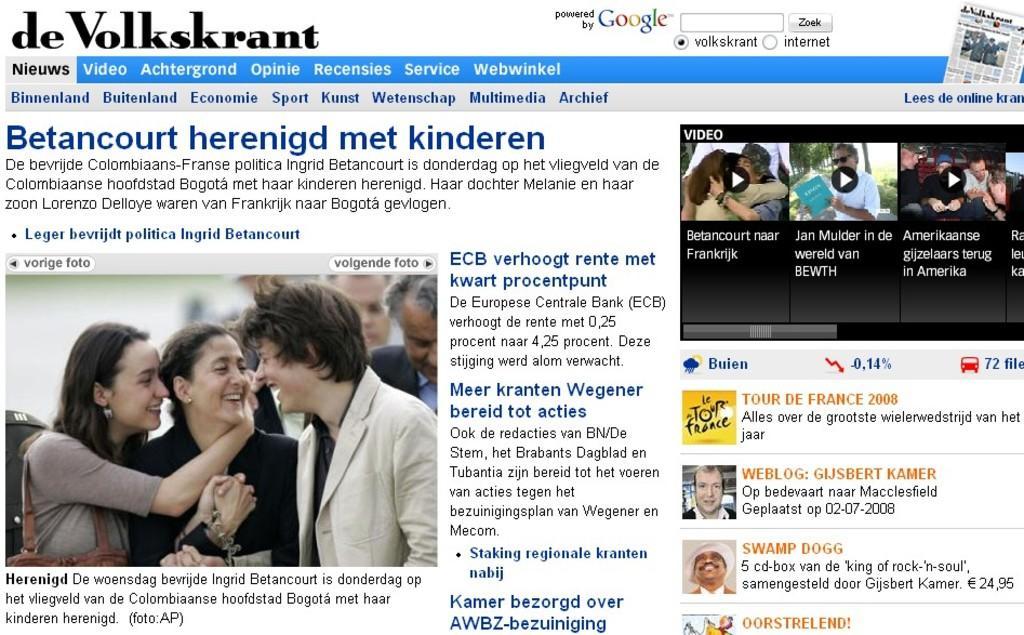Please provide a concise description of this image. This is a web page and here we can see some text and we can see some pictures of people and some are holding objects. 